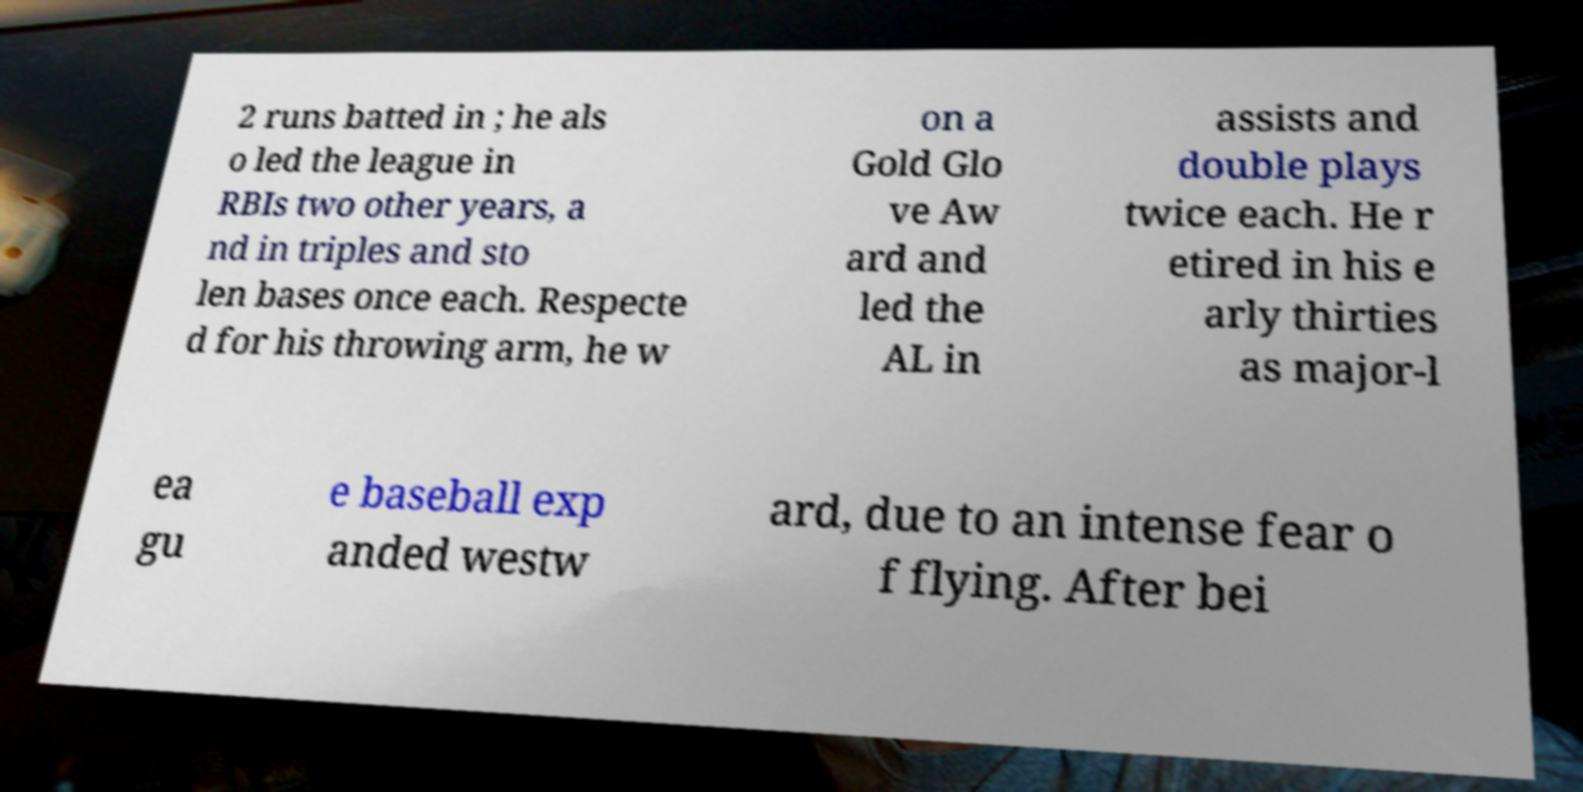Can you read and provide the text displayed in the image?This photo seems to have some interesting text. Can you extract and type it out for me? 2 runs batted in ; he als o led the league in RBIs two other years, a nd in triples and sto len bases once each. Respecte d for his throwing arm, he w on a Gold Glo ve Aw ard and led the AL in assists and double plays twice each. He r etired in his e arly thirties as major-l ea gu e baseball exp anded westw ard, due to an intense fear o f flying. After bei 